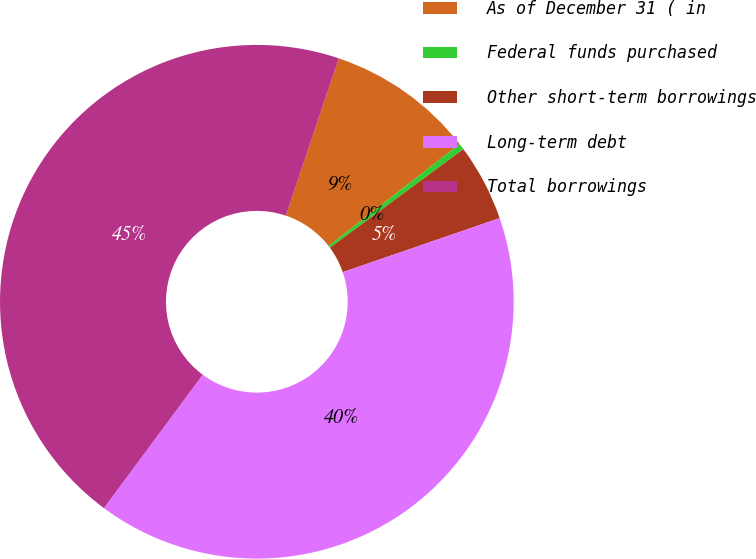Convert chart. <chart><loc_0><loc_0><loc_500><loc_500><pie_chart><fcel>As of December 31 ( in<fcel>Federal funds purchased<fcel>Other short-term borrowings<fcel>Long-term debt<fcel>Total borrowings<nl><fcel>9.31%<fcel>0.39%<fcel>4.85%<fcel>40.43%<fcel>45.02%<nl></chart> 